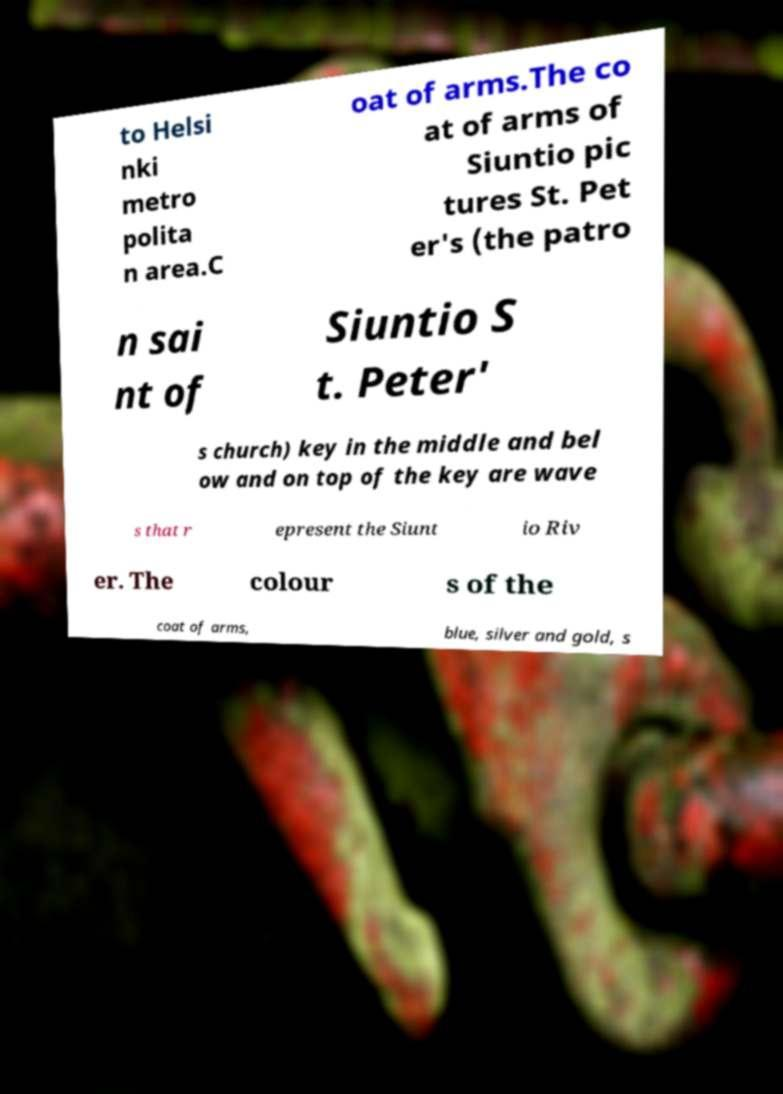I need the written content from this picture converted into text. Can you do that? to Helsi nki metro polita n area.C oat of arms.The co at of arms of Siuntio pic tures St. Pet er's (the patro n sai nt of Siuntio S t. Peter' s church) key in the middle and bel ow and on top of the key are wave s that r epresent the Siunt io Riv er. The colour s of the coat of arms, blue, silver and gold, s 